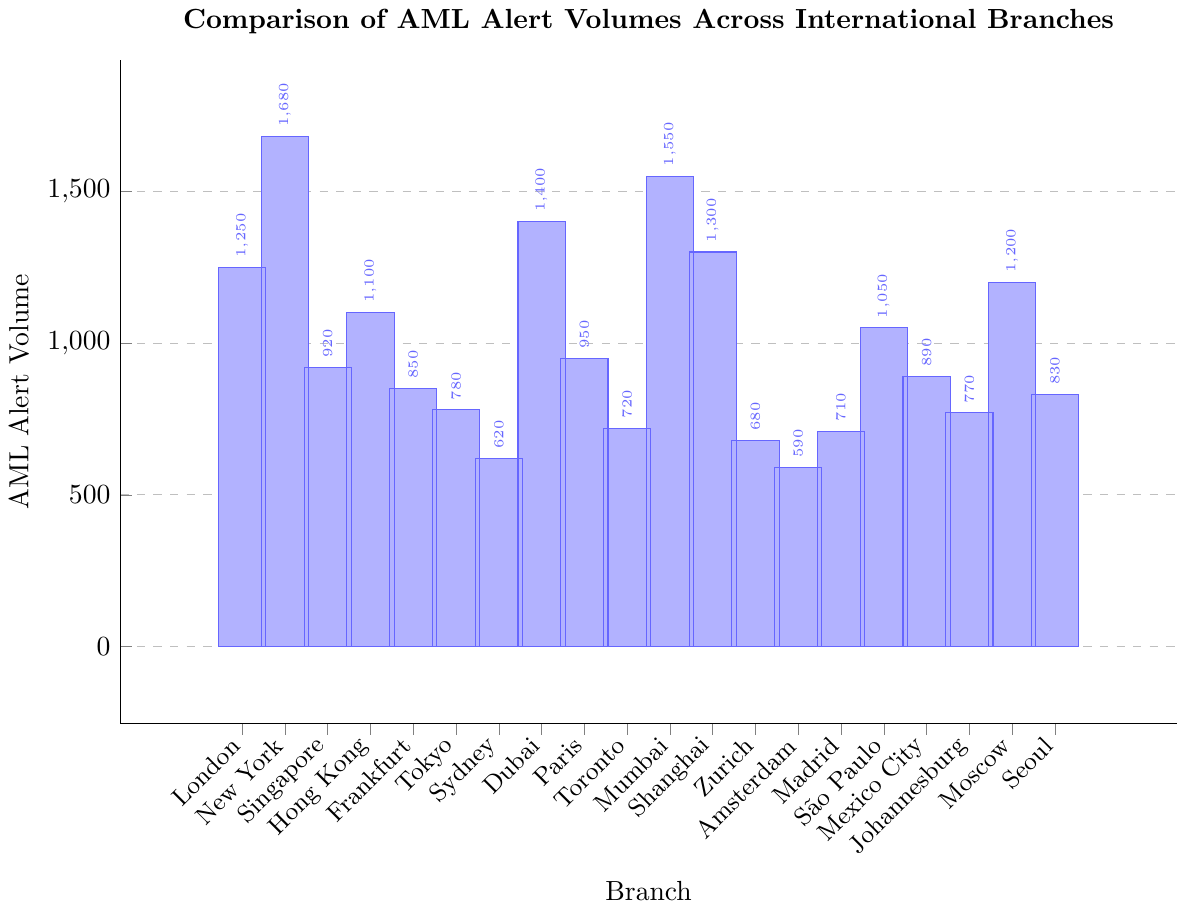Which branch has the highest AML alert volume? Refer to the figure and identify the branch with the tallest bar. New York has the tallest bar, indicating it has the highest AML alert volume.
Answer: New York Which branch has the lowest AML alert volume? Look for the branch with the shortest bar. Amsterdam has the shortest bar, indicating it has the lowest AML alert volume.
Answer: Amsterdam How much higher is the AML alert volume in Tokyo compared to Zurich? Identify the heights of the bars for Tokyo and Zurich. Tokyo has 780 alerts and Zurich has 680 alerts. The difference is 780 - 680 = 100.
Answer: 100 What is the combined AML alert volume for the branches in London and Paris? Add the AML alert volumes for London and Paris. London has 1250 alerts, and Paris has 950 alerts. The combined volume is 1250 + 950 = 2200.
Answer: 2200 Is the AML alert volume in Dubai greater than in Seoul? Compare the heights of the bars for Dubai and Seoul. Dubai has 1400 alerts, and Seoul has 830 alerts. Since 1400 > 830, Dubai has a greater volume.
Answer: Yes What is the average AML alert volume for the branches in Singapore, Hong Kong, and Frankfurt? First, find the alert volumes for the three branches: Singapore (920), Hong Kong (1100), and Frankfurt (850). Add them up: 920 + 1100 + 850 = 2870. Divide by 3 to find the average: 2870 / 3 ≈ 956.67.
Answer: 956.67 How does the AML alert volume of São Paulo compare to Mumbai? Look at the heights of the bars for São Paulo and Mumbai. São Paulo has 1050 alerts, while Mumbai has 1550 alerts. São Paulo has less volume than Mumbai.
Answer: Less What is the median AML alert volume for all the branches? Order the AML alert volumes from smallest to largest and find the middle value. Ordered volumes: 590, 620, 680, 710, 720, 770, 780, 830, 850, 890, 920, 950, 1050, 1100, 1200, 1250, 1300, 1400, 1550, 1680. The median value (the middle of the 20 data points) is the average of the 10th and 11th values: (890 + 920) / 2 = 905.
Answer: 905 Which branch has the AML alert volume closest to 1000? Identify the data point (bar) closest to 1000. Paris has 950 alerts, which is the closest to 1000 compared to other branches.
Answer: Paris 